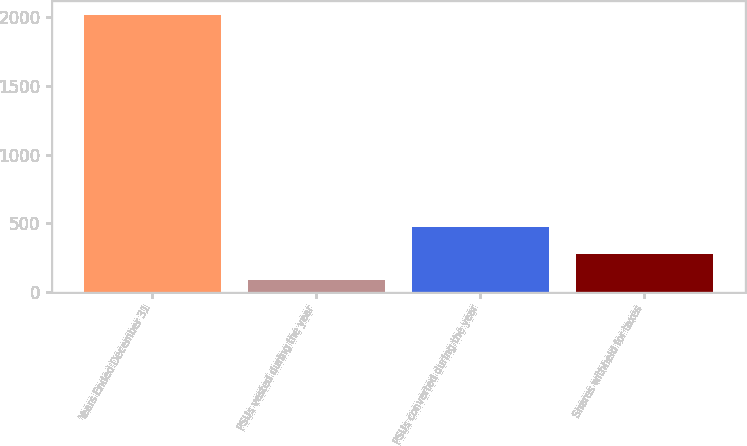<chart> <loc_0><loc_0><loc_500><loc_500><bar_chart><fcel>Years Ended December 31<fcel>PSUs vested during the year<fcel>PSUs converted during the year<fcel>Shares withheld for taxes<nl><fcel>2014<fcel>85<fcel>470.8<fcel>277.9<nl></chart> 